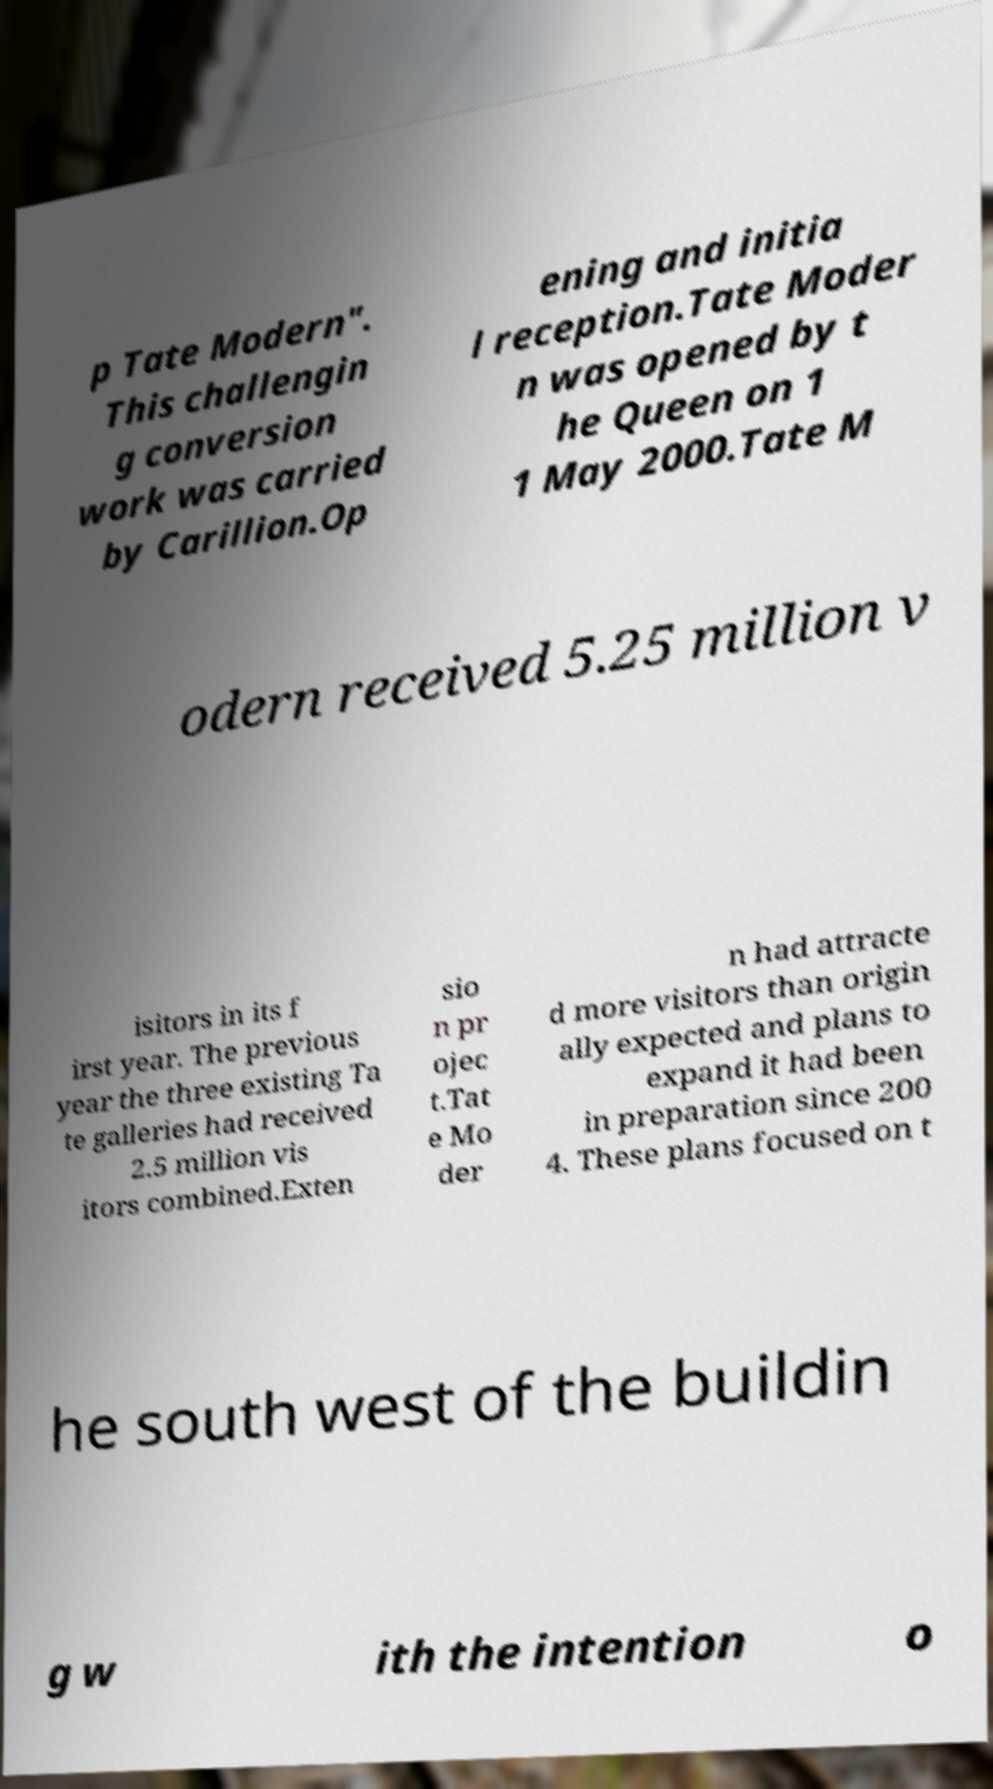Could you extract and type out the text from this image? p Tate Modern". This challengin g conversion work was carried by Carillion.Op ening and initia l reception.Tate Moder n was opened by t he Queen on 1 1 May 2000.Tate M odern received 5.25 million v isitors in its f irst year. The previous year the three existing Ta te galleries had received 2.5 million vis itors combined.Exten sio n pr ojec t.Tat e Mo der n had attracte d more visitors than origin ally expected and plans to expand it had been in preparation since 200 4. These plans focused on t he south west of the buildin g w ith the intention o 